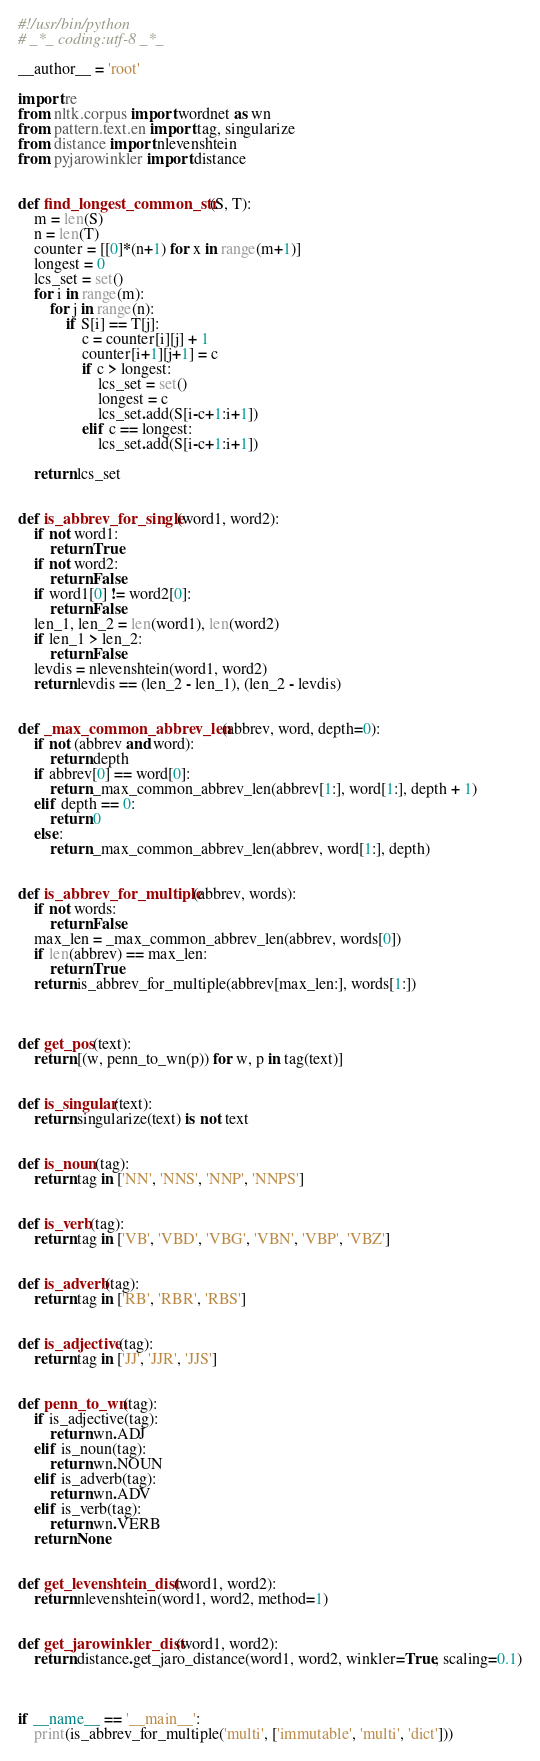Convert code to text. <code><loc_0><loc_0><loc_500><loc_500><_Python_>#!/usr/bin/python
# _*_ coding:utf-8 _*_

__author__ = 'root'

import re
from nltk.corpus import wordnet as wn
from pattern.text.en import tag, singularize
from distance import nlevenshtein
from pyjarowinkler import distance


def find_longest_common_str(S, T):
    m = len(S)
    n = len(T)
    counter = [[0]*(n+1) for x in range(m+1)]
    longest = 0
    lcs_set = set()
    for i in range(m):
        for j in range(n):
            if S[i] == T[j]:
                c = counter[i][j] + 1
                counter[i+1][j+1] = c
                if c > longest:
                    lcs_set = set()
                    longest = c
                    lcs_set.add(S[i-c+1:i+1])
                elif c == longest:
                    lcs_set.add(S[i-c+1:i+1])

    return lcs_set


def is_abbrev_for_single(word1, word2):
    if not word1:
        return True
    if not word2:
        return False
    if word1[0] != word2[0]:
        return False
    len_1, len_2 = len(word1), len(word2)
    if len_1 > len_2:
        return False
    levdis = nlevenshtein(word1, word2)
    return levdis == (len_2 - len_1), (len_2 - levdis)


def _max_common_abbrev_len(abbrev, word, depth=0):
    if not (abbrev and word):
        return depth
    if abbrev[0] == word[0]:
        return _max_common_abbrev_len(abbrev[1:], word[1:], depth + 1)
    elif depth == 0:
        return 0
    else:
        return _max_common_abbrev_len(abbrev, word[1:], depth)


def is_abbrev_for_multiple(abbrev, words):
    if not words:
        return False
    max_len = _max_common_abbrev_len(abbrev, words[0])
    if len(abbrev) == max_len:
        return True
    return is_abbrev_for_multiple(abbrev[max_len:], words[1:])



def get_pos(text):
    return [(w, penn_to_wn(p)) for w, p in tag(text)]


def is_singular(text):
    return singularize(text) is not text


def is_noun(tag):
    return tag in ['NN', 'NNS', 'NNP', 'NNPS']


def is_verb(tag):
    return tag in ['VB', 'VBD', 'VBG', 'VBN', 'VBP', 'VBZ']


def is_adverb(tag):
    return tag in ['RB', 'RBR', 'RBS']


def is_adjective(tag):
    return tag in ['JJ', 'JJR', 'JJS']


def penn_to_wn(tag):
    if is_adjective(tag):
        return wn.ADJ
    elif is_noun(tag):
        return wn.NOUN
    elif is_adverb(tag):
        return wn.ADV
    elif is_verb(tag):
        return wn.VERB
    return None


def get_levenshtein_dist(word1, word2):
    return nlevenshtein(word1, word2, method=1)


def get_jarowinkler_dist(word1, word2):
    return distance.get_jaro_distance(word1, word2, winkler=True, scaling=0.1)



if __name__ == '__main__':
    print(is_abbrev_for_multiple('multi', ['immutable', 'multi', 'dict']))
</code> 